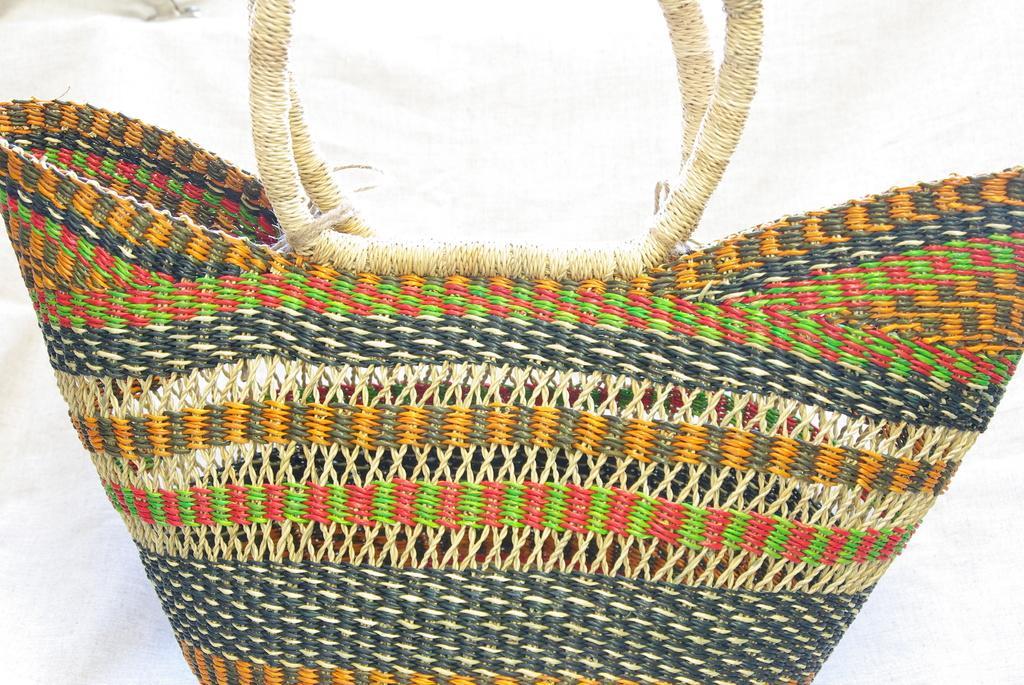How would you summarize this image in a sentence or two? This picture is mainly highlighted with a handbag made of wool. 